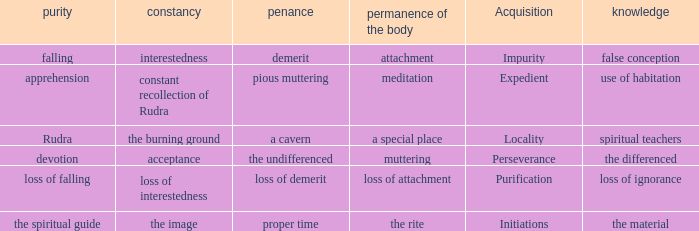 what's the permanence of the body where purity is apprehension Meditation. 